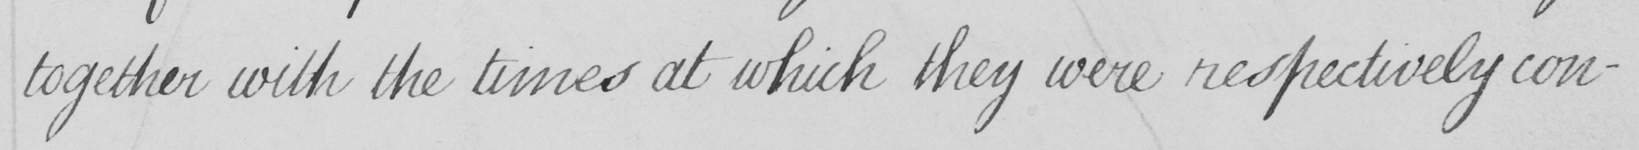What does this handwritten line say? together with the times at which they were respectively con- 